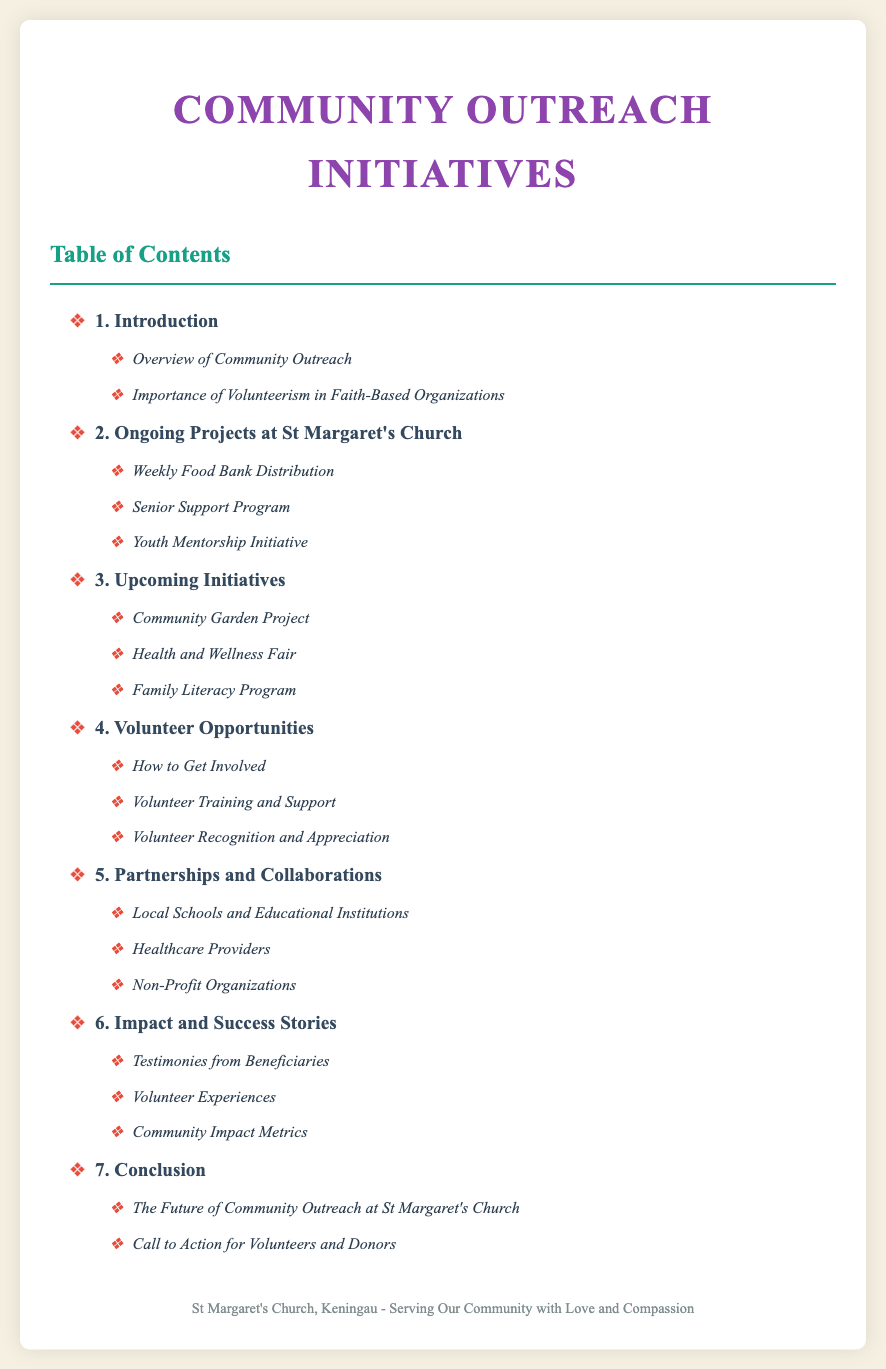What is the title of the document? The title of the document is stated at the top of the page.
Answer: Community Outreach Initiatives - St Margaret's Church, Keningau How many ongoing projects are mentioned? The number of ongoing projects is listed in the section under ongoing projects.
Answer: 3 What is the section highlighting the importance of volunteerism? The importance of volunteerism is discussed in a specific section listed in the introduction.
Answer: Importance of Volunteerism in Faith-Based Organizations Which project focuses on supporting seniors? The specific project is mentioned as part of the ongoing projects section.
Answer: Senior Support Program What should individuals do to get involved? The process for participation is detailed under a dedicated section for volunteer opportunities.
Answer: How to Get Involved What kind of event is planned for health awareness? This initiative is specified in upcoming projects related to health.
Answer: Health and Wellness Fair What is included in the chapter about impact? The chapter details the effects of the outreach initiatives and includes various aspects.
Answer: Community Impact Metrics What does the conclusion encourage from volunteers? The final section of the document calls for specific actions related to volunteer involvement.
Answer: Call to Action for Volunteers and Donors 